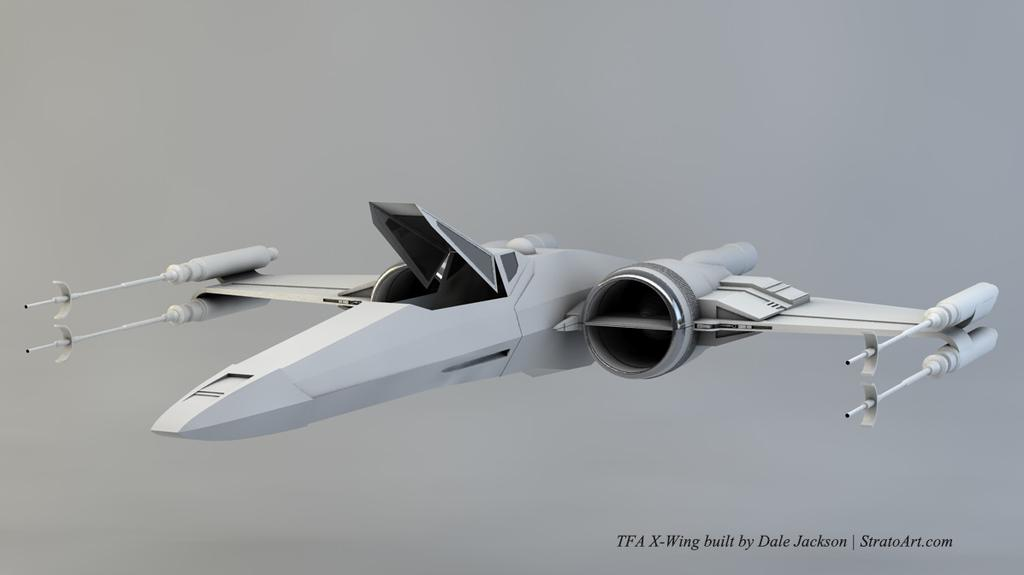What is the main subject of the picture? The main subject of the picture is an animated image of a plane. Is there any additional information or text visible in the image? Yes, there is a watermark in the bottom right corner of the image. What type of apparel are the ants wearing in the image? There are no ants or apparel present in the image; it features an animated image of a plane and a watermark. What reward can be seen in the image for completing the task? There is no task or reward depicted in the image; it only contains an animated plane and a watermark. 